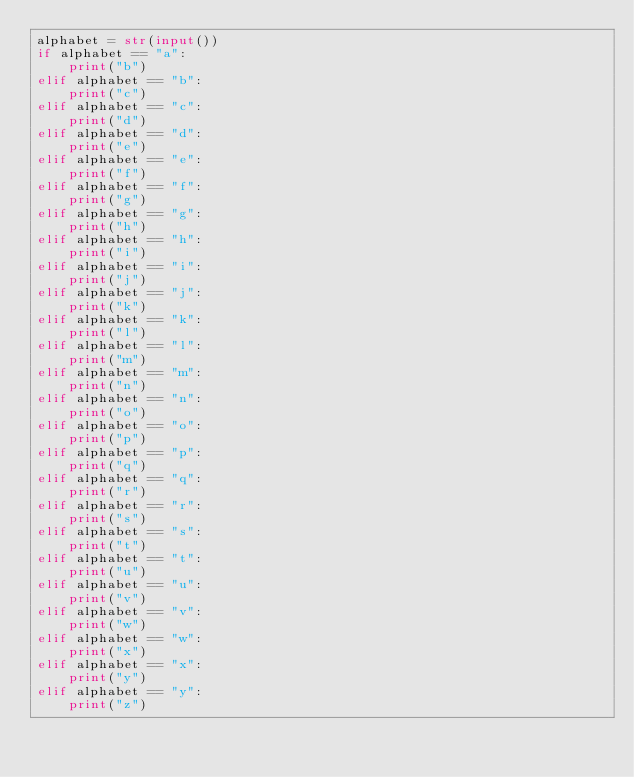Convert code to text. <code><loc_0><loc_0><loc_500><loc_500><_Python_>alphabet = str(input())
if alphabet == "a":
	print("b")
elif alphabet == "b":
	print("c")
elif alphabet == "c":
	print("d")
elif alphabet == "d":
	print("e")
elif alphabet == "e":
	print("f")
elif alphabet == "f":
	print("g")
elif alphabet == "g":
	print("h")
elif alphabet == "h":
	print("i")
elif alphabet == "i":
	print("j")
elif alphabet == "j":
	print("k")
elif alphabet == "k":
	print("l")
elif alphabet == "l":
	print("m")
elif alphabet == "m":
	print("n")
elif alphabet == "n":
	print("o")
elif alphabet == "o":
	print("p")
elif alphabet == "p":
	print("q")
elif alphabet == "q":
	print("r")
elif alphabet == "r":
	print("s")
elif alphabet == "s":
	print("t")
elif alphabet == "t":
	print("u")
elif alphabet == "u":
	print("v")
elif alphabet == "v":
	print("w")
elif alphabet == "w":
	print("x")
elif alphabet == "x":
	print("y")
elif alphabet == "y":
	print("z")

</code> 